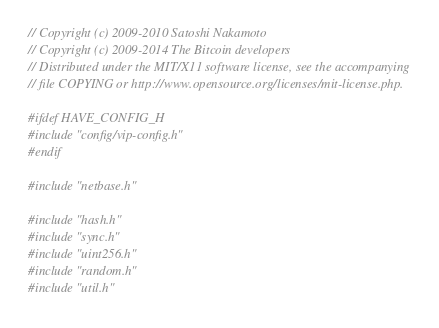Convert code to text. <code><loc_0><loc_0><loc_500><loc_500><_C++_>// Copyright (c) 2009-2010 Satoshi Nakamoto
// Copyright (c) 2009-2014 The Bitcoin developers
// Distributed under the MIT/X11 software license, see the accompanying
// file COPYING or http://www.opensource.org/licenses/mit-license.php.

#ifdef HAVE_CONFIG_H
#include "config/vip-config.h"
#endif

#include "netbase.h"

#include "hash.h"
#include "sync.h"
#include "uint256.h"
#include "random.h"
#include "util.h"</code> 